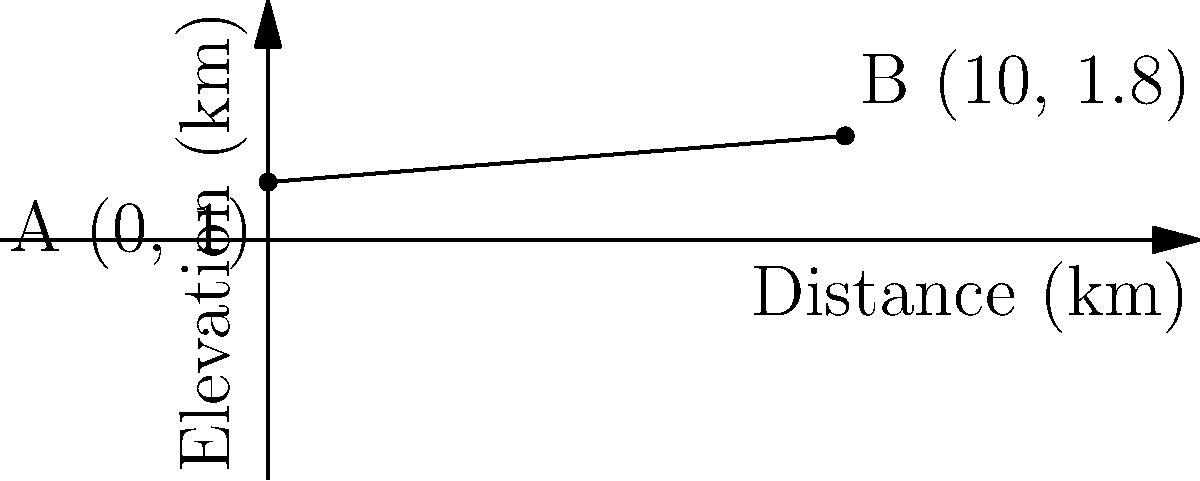During the Adriatica Ionica Race, you encounter a challenging hill climb. The starting point A is at an elevation of 1 km, and after cycling 10 km, you reach point B at an elevation of 1.8 km. Using the coordinate points A(0, 1) and B(10, 1.8), calculate the average slope of this hill climb. To find the average slope of the hill climb, we'll use the slope formula:

$$ \text{Slope} = \frac{\text{Change in y}}{\text{Change in x}} = \frac{y_2 - y_1}{x_2 - x_1} $$

Given:
- Point A: (0, 1)
- Point B: (10, 1.8)

Step 1: Identify the coordinates
$x_1 = 0$, $y_1 = 1$
$x_2 = 10$, $y_2 = 1.8$

Step 2: Calculate the change in y (rise)
$\text{Change in y} = y_2 - y_1 = 1.8 - 1 = 0.8$ km

Step 3: Calculate the change in x (run)
$\text{Change in x} = x_2 - x_1 = 10 - 0 = 10$ km

Step 4: Apply the slope formula
$$ \text{Slope} = \frac{0.8}{10} = 0.08 $$

Step 5: Convert to percentage
$0.08 \times 100\% = 8\%$

Therefore, the average slope of the hill climb is 0.08 or 8%.
Answer: 8% 